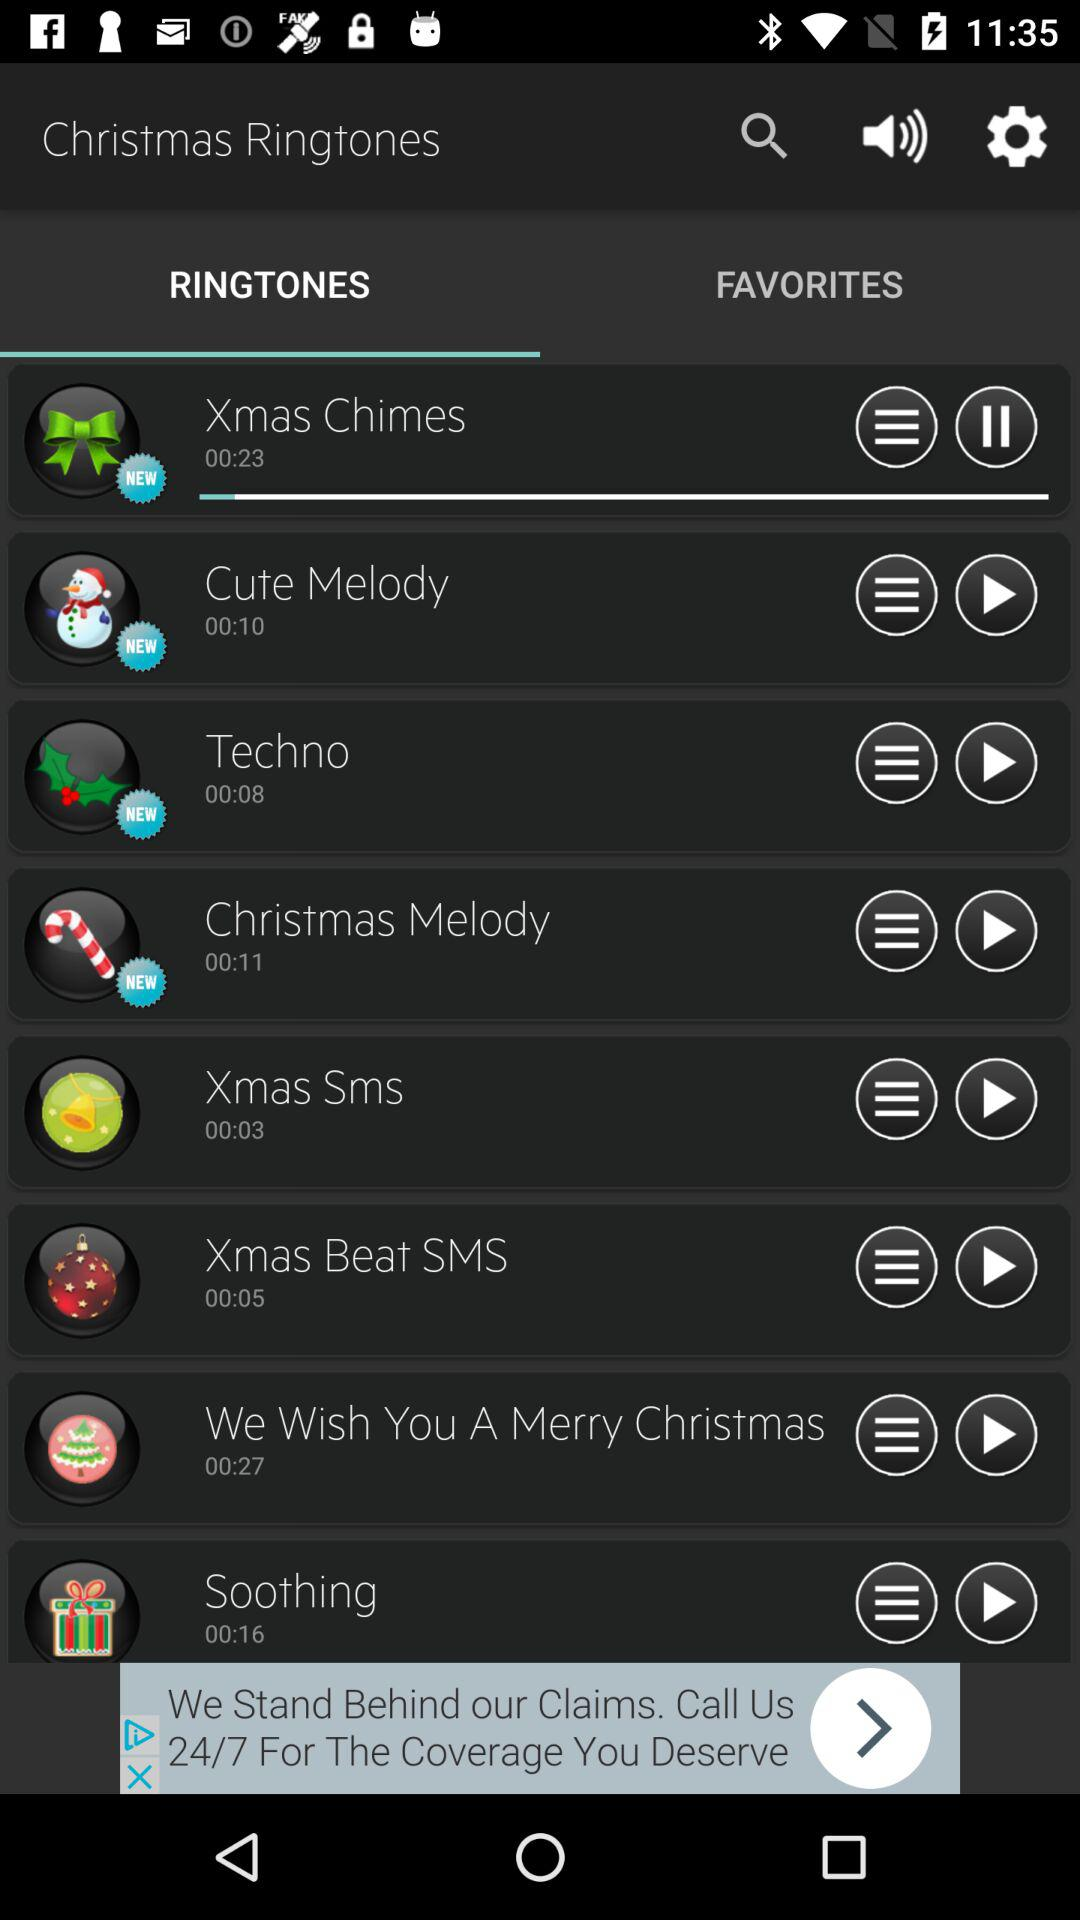Which ringtone is playing? The ringtone that is playing is "Xmas Chimes". 